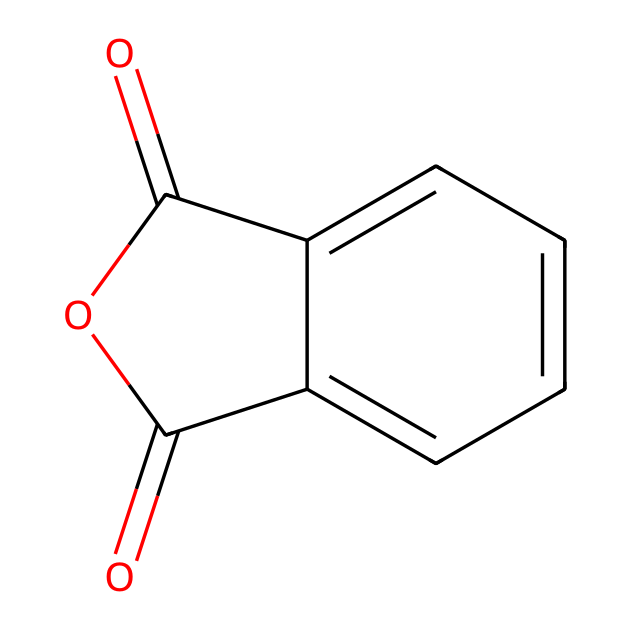What is the main functional group in phthalic anhydride? The structure includes a cyclic anhydride functional group, identifiable by the two carbonyls (C=O) adjacent to an oxygen in a ring.
Answer: anhydride How many carbon atoms are present in the structure? By examining the skeletal representation, there are eight carbon atoms in total—six from the phenyl ring and two in the anhydride part.
Answer: eight How many oxygen atoms are present in phthalic anhydride? Inspecting the structure shows there are three oxygen atoms: two in the carbonyl groups and one in the anhydride ring.
Answer: three What is the total number of π bonds present in phthalic anhydride? The structure has two carbonyl groups (each with one π bond) and one double bond in the aromatic ring contributing another π bond, totaling four π bonds.
Answer: four What type of reactions commonly involve phthalic anhydride? Phthalic anhydride is commonly involved in condensation reactions with alcohols to form esters.
Answer: condensation What structural feature indicates that phthalic anhydride is an acid anhydride? The presence of the cyclic anhydride with two carbonyl groups indicates its classification as an acid anhydride.
Answer: cyclic anhydride How does the molecular structure of phthalic anhydride affect its reactivity? The high electron density around the carbonyl groups makes it highly reactive towards nucleophiles, facilitating various chemical reactions.
Answer: high reactivity 